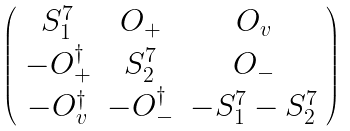<formula> <loc_0><loc_0><loc_500><loc_500>\left ( \begin{array} { c c c } { { S _ { 1 } ^ { 7 } } } & { { { O } _ { + } } } & { { { O } _ { v } } } \\ { { - { O } _ { + } ^ { \dagger } } } & { { S _ { 2 } ^ { 7 } } } & { { { O } _ { - } } } \\ { { - { O } _ { v } ^ { \dagger } } } & { { - { O } _ { - } ^ { \dagger } } } & { { - S _ { 1 } ^ { 7 } - S _ { 2 } ^ { 7 } } } \end{array} \right )</formula> 